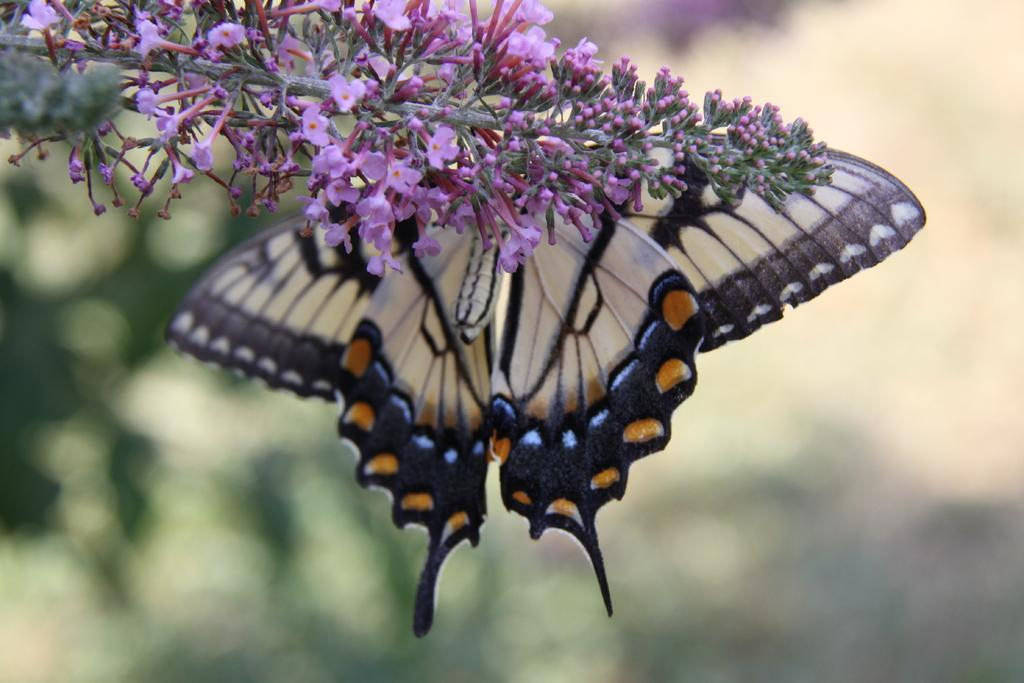What is the main subject in the foreground of the image? There is a white colored butterfly in the foreground of the image. What is the butterfly resting on? The butterfly is on a plant. What color are the flowers on the plant? The flowers on the plant are pink colored. How would you describe the background of the image? The background of the image is blurred. What year is depicted in the image? The image does not depict a specific year; it is a photograph of a butterfly on a plant. 